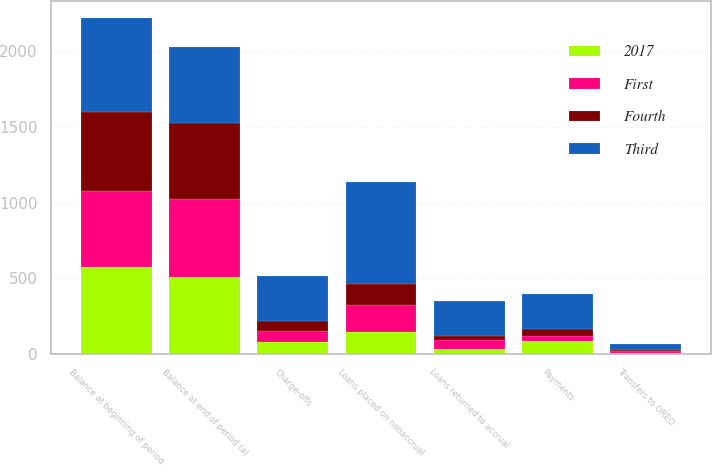Convert chart to OTSL. <chart><loc_0><loc_0><loc_500><loc_500><stacked_bar_chart><ecel><fcel>Balance at beginning of period<fcel>Loans placed on nonaccrual<fcel>Charge-offs<fcel>Payments<fcel>Transfers to OREO<fcel>Loans returned to accrual<fcel>Balance at end of period (a)<nl><fcel>Third<fcel>625<fcel>679<fcel>297<fcel>227<fcel>37<fcel>231<fcel>503<nl><fcel>Fourth<fcel>517<fcel>137<fcel>67<fcel>52<fcel>8<fcel>24<fcel>503<nl><fcel>First<fcel>507<fcel>181<fcel>71<fcel>32<fcel>10<fcel>57<fcel>517<nl><fcel>2017<fcel>573<fcel>143<fcel>82<fcel>84<fcel>8<fcel>35<fcel>507<nl></chart> 